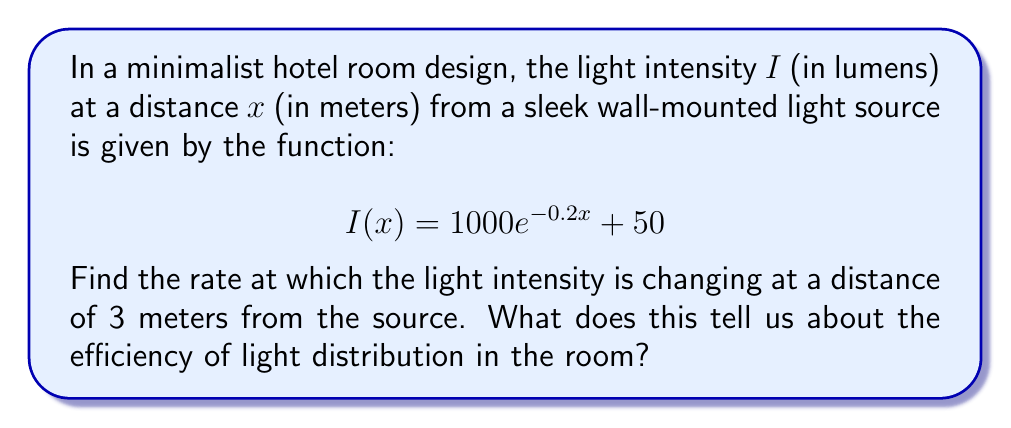Provide a solution to this math problem. To find the rate at which the light intensity is changing at a distance of 3 meters, we need to calculate the derivative of $I(x)$ and evaluate it at $x = 3$.

Step 1: Calculate the derivative of $I(x)$
$$\frac{d}{dx}I(x) = \frac{d}{dx}(1000e^{-0.2x} + 50)$$
$$I'(x) = 1000 \cdot (-0.2)e^{-0.2x} + 0$$
$$I'(x) = -200e^{-0.2x}$$

Step 2: Evaluate $I'(x)$ at $x = 3$
$$I'(3) = -200e^{-0.2(3)}$$
$$I'(3) = -200e^{-0.6}$$
$$I'(3) \approx -109.75$$

Step 3: Interpret the result
The rate of change at 3 meters is approximately -109.75 lumens per meter. The negative value indicates that the light intensity is decreasing as we move away from the source.

This rate of change tells us about the efficiency of light distribution in the room:
1. The light intensity decreases rapidly (about 110 lumens per meter at 3 meters distance).
2. This rapid decrease suggests that the light distribution may not be very uniform across the room.
3. For a minimalist design, this could mean that additional light sources or reflective surfaces might be needed to achieve a more even illumination throughout the space.
Answer: $I'(3) \approx -109.75$ lumens/meter 